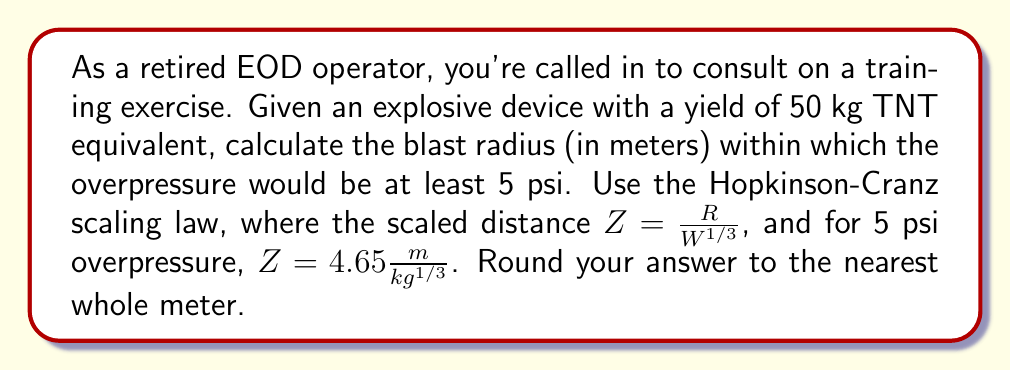Show me your answer to this math problem. To solve this problem, we'll use the Hopkinson-Cranz scaling law and the given information:

1. Yield (W) = 50 kg TNT equivalent
2. Scaled distance (Z) for 5 psi overpressure = $4.65 \frac{m}{kg^{1/3}}$

The Hopkinson-Cranz scaling law is given by:

$$ Z = \frac{R}{W^{1/3}} $$

Where:
- Z is the scaled distance
- R is the actual distance (blast radius)
- W is the yield in kg TNT equivalent

We need to solve for R:

$$ R = Z \cdot W^{1/3} $$

Substituting the known values:

$$ R = 4.65 \frac{m}{kg^{1/3}} \cdot (50 \text{ kg})^{1/3} $$

Now, let's calculate:

1. First, calculate $W^{1/3}$:
   $$ (50)^{1/3} \approx 3.684 $$

2. Multiply this by the scaled distance:
   $$ R = 4.65 \cdot 3.684 \approx 17.1306 \text{ m} $$

3. Rounding to the nearest whole meter:
   $$ R \approx 17 \text{ m} $$
Answer: The blast radius within which the overpressure would be at least 5 psi is approximately 17 meters. 